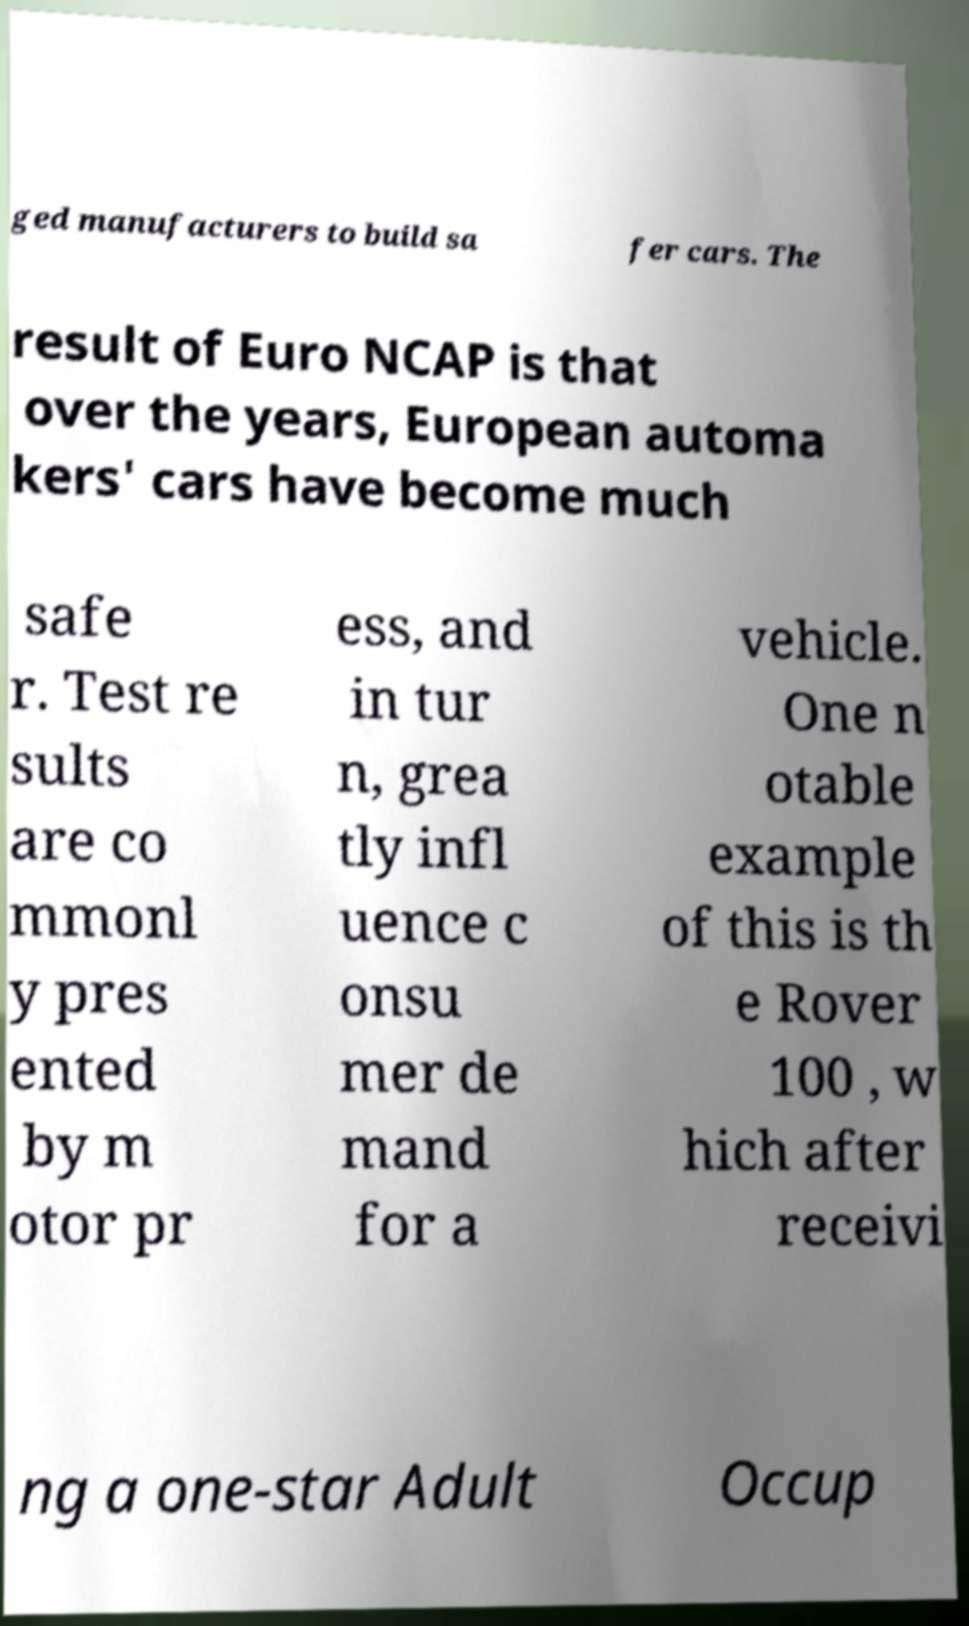Please read and relay the text visible in this image. What does it say? ged manufacturers to build sa fer cars. The result of Euro NCAP is that over the years, European automa kers' cars have become much safe r. Test re sults are co mmonl y pres ented by m otor pr ess, and in tur n, grea tly infl uence c onsu mer de mand for a vehicle. One n otable example of this is th e Rover 100 , w hich after receivi ng a one-star Adult Occup 